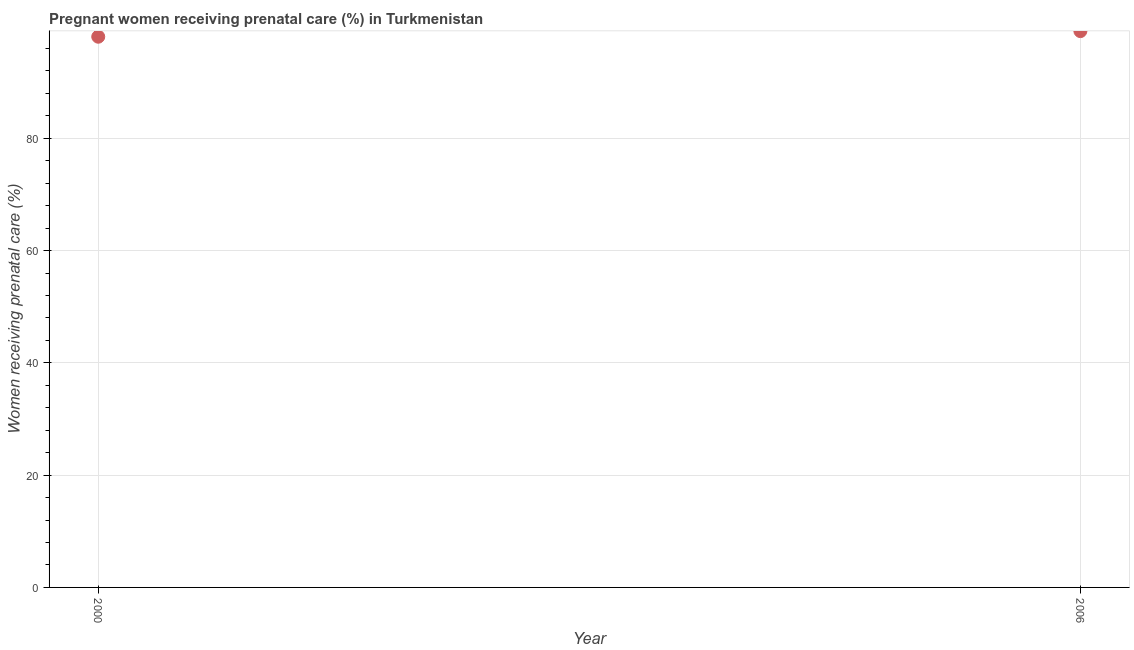What is the percentage of pregnant women receiving prenatal care in 2000?
Your answer should be compact. 98.1. Across all years, what is the maximum percentage of pregnant women receiving prenatal care?
Keep it short and to the point. 99.1. Across all years, what is the minimum percentage of pregnant women receiving prenatal care?
Make the answer very short. 98.1. What is the sum of the percentage of pregnant women receiving prenatal care?
Provide a succinct answer. 197.2. What is the average percentage of pregnant women receiving prenatal care per year?
Keep it short and to the point. 98.6. What is the median percentage of pregnant women receiving prenatal care?
Keep it short and to the point. 98.6. Do a majority of the years between 2000 and 2006 (inclusive) have percentage of pregnant women receiving prenatal care greater than 64 %?
Your answer should be very brief. Yes. What is the ratio of the percentage of pregnant women receiving prenatal care in 2000 to that in 2006?
Your answer should be compact. 0.99. Is the percentage of pregnant women receiving prenatal care in 2000 less than that in 2006?
Your answer should be very brief. Yes. In how many years, is the percentage of pregnant women receiving prenatal care greater than the average percentage of pregnant women receiving prenatal care taken over all years?
Offer a terse response. 1. Does the percentage of pregnant women receiving prenatal care monotonically increase over the years?
Make the answer very short. Yes. What is the difference between two consecutive major ticks on the Y-axis?
Your answer should be very brief. 20. Does the graph contain any zero values?
Provide a short and direct response. No. What is the title of the graph?
Offer a very short reply. Pregnant women receiving prenatal care (%) in Turkmenistan. What is the label or title of the X-axis?
Give a very brief answer. Year. What is the label or title of the Y-axis?
Your response must be concise. Women receiving prenatal care (%). What is the Women receiving prenatal care (%) in 2000?
Offer a very short reply. 98.1. What is the Women receiving prenatal care (%) in 2006?
Your answer should be compact. 99.1. What is the difference between the Women receiving prenatal care (%) in 2000 and 2006?
Your answer should be very brief. -1. What is the ratio of the Women receiving prenatal care (%) in 2000 to that in 2006?
Keep it short and to the point. 0.99. 